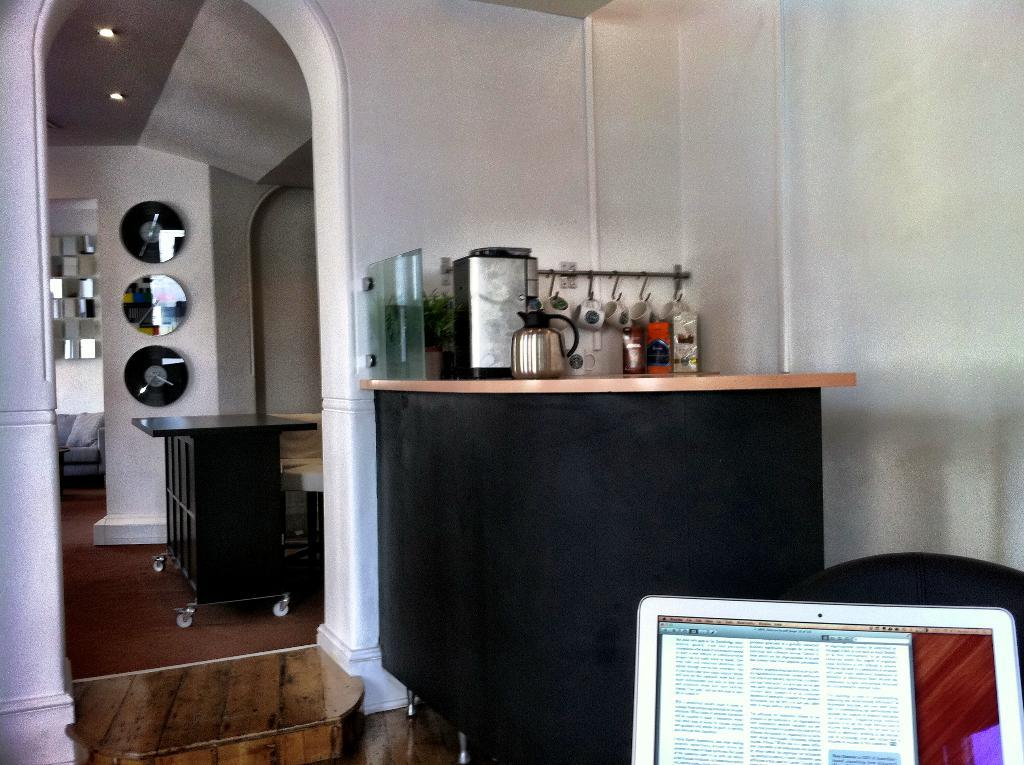What is the main object in the image? There is a screen in the image. What other objects can be seen in the image? There is a kettle, objects on a table, a wall, disks on a wall, a table, and a sofa in the image. What is located at the top of the image? There are lights at the top of the image. How many thumbs are visible in the image? There are no thumbs visible in the image. Is the image completely quiet? The image itself is silent, but we cannot determine the level of noise in the depicted scene. 